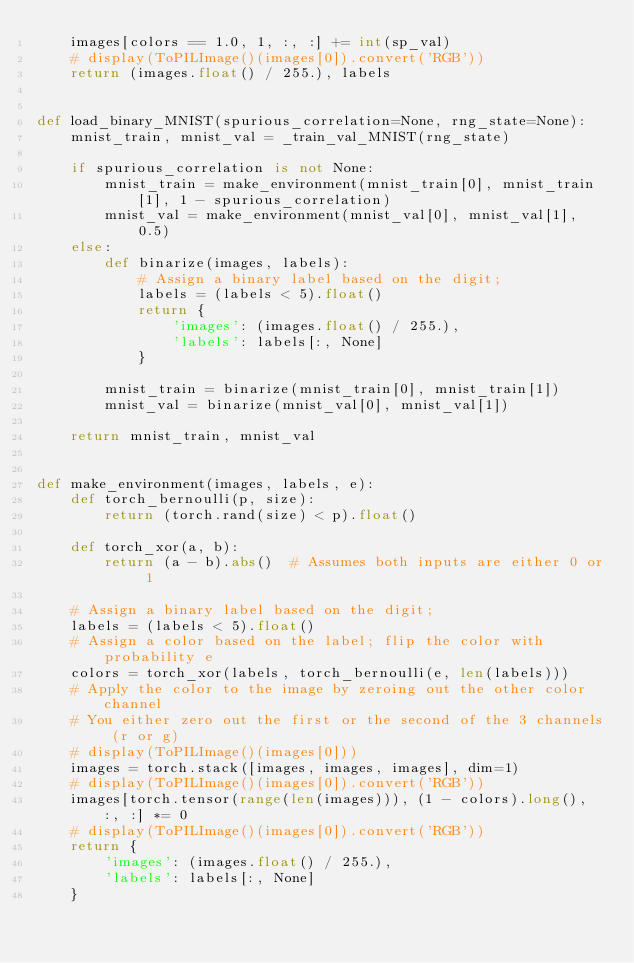<code> <loc_0><loc_0><loc_500><loc_500><_Python_>    images[colors == 1.0, 1, :, :] += int(sp_val)
    # display(ToPILImage()(images[0]).convert('RGB'))
    return (images.float() / 255.), labels


def load_binary_MNIST(spurious_correlation=None, rng_state=None):
    mnist_train, mnist_val = _train_val_MNIST(rng_state)

    if spurious_correlation is not None:
        mnist_train = make_environment(mnist_train[0], mnist_train[1], 1 - spurious_correlation)
        mnist_val = make_environment(mnist_val[0], mnist_val[1], 0.5)
    else:
        def binarize(images, labels):
            # Assign a binary label based on the digit;
            labels = (labels < 5).float()
            return {
                'images': (images.float() / 255.),
                'labels': labels[:, None]
            }

        mnist_train = binarize(mnist_train[0], mnist_train[1])
        mnist_val = binarize(mnist_val[0], mnist_val[1])

    return mnist_train, mnist_val


def make_environment(images, labels, e):
    def torch_bernoulli(p, size):
        return (torch.rand(size) < p).float()

    def torch_xor(a, b):
        return (a - b).abs()  # Assumes both inputs are either 0 or 1

    # Assign a binary label based on the digit;
    labels = (labels < 5).float()
    # Assign a color based on the label; flip the color with probability e
    colors = torch_xor(labels, torch_bernoulli(e, len(labels)))
    # Apply the color to the image by zeroing out the other color channel
    # You either zero out the first or the second of the 3 channels (r or g)
    # display(ToPILImage()(images[0]))
    images = torch.stack([images, images, images], dim=1)
    # display(ToPILImage()(images[0]).convert('RGB'))
    images[torch.tensor(range(len(images))), (1 - colors).long(), :, :] *= 0
    # display(ToPILImage()(images[0]).convert('RGB'))
    return {
        'images': (images.float() / 255.),
        'labels': labels[:, None]
    }
</code> 